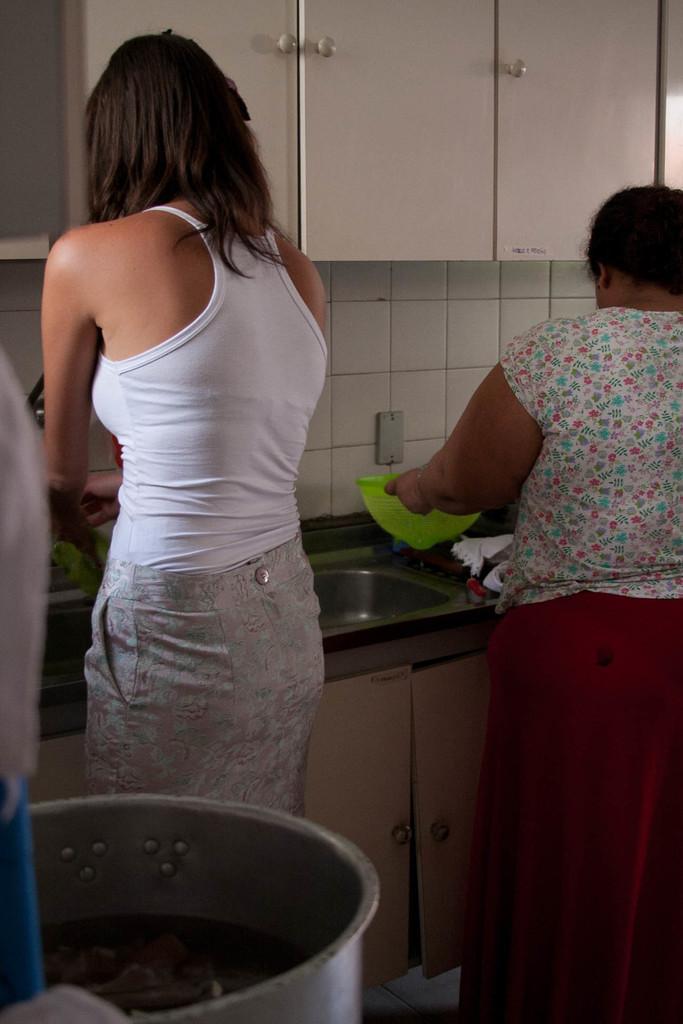Please provide a concise description of this image. On the left side, there is a woman in a white color T-shirt, standing. Behind her, there is a tin. On the right side, there is another woman holding a green color bowl and standing in front of a table, on which there is a sink. This table is a having cupboard. Above this table, there are cupboards attached to the white wall. 